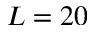Convert formula to latex. <formula><loc_0><loc_0><loc_500><loc_500>L = 2 0</formula> 